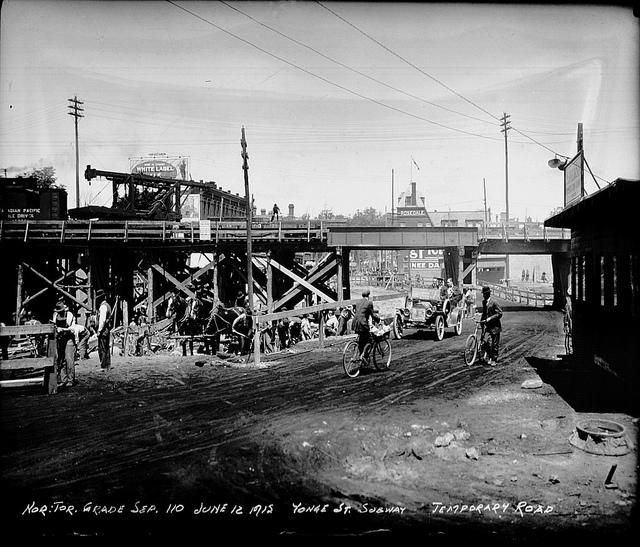Is this photo an old one?
Be succinct. Yes. Does the photograph depict a construction site?
Give a very brief answer. Yes. Was this photo take in 2015?
Answer briefly. No. 